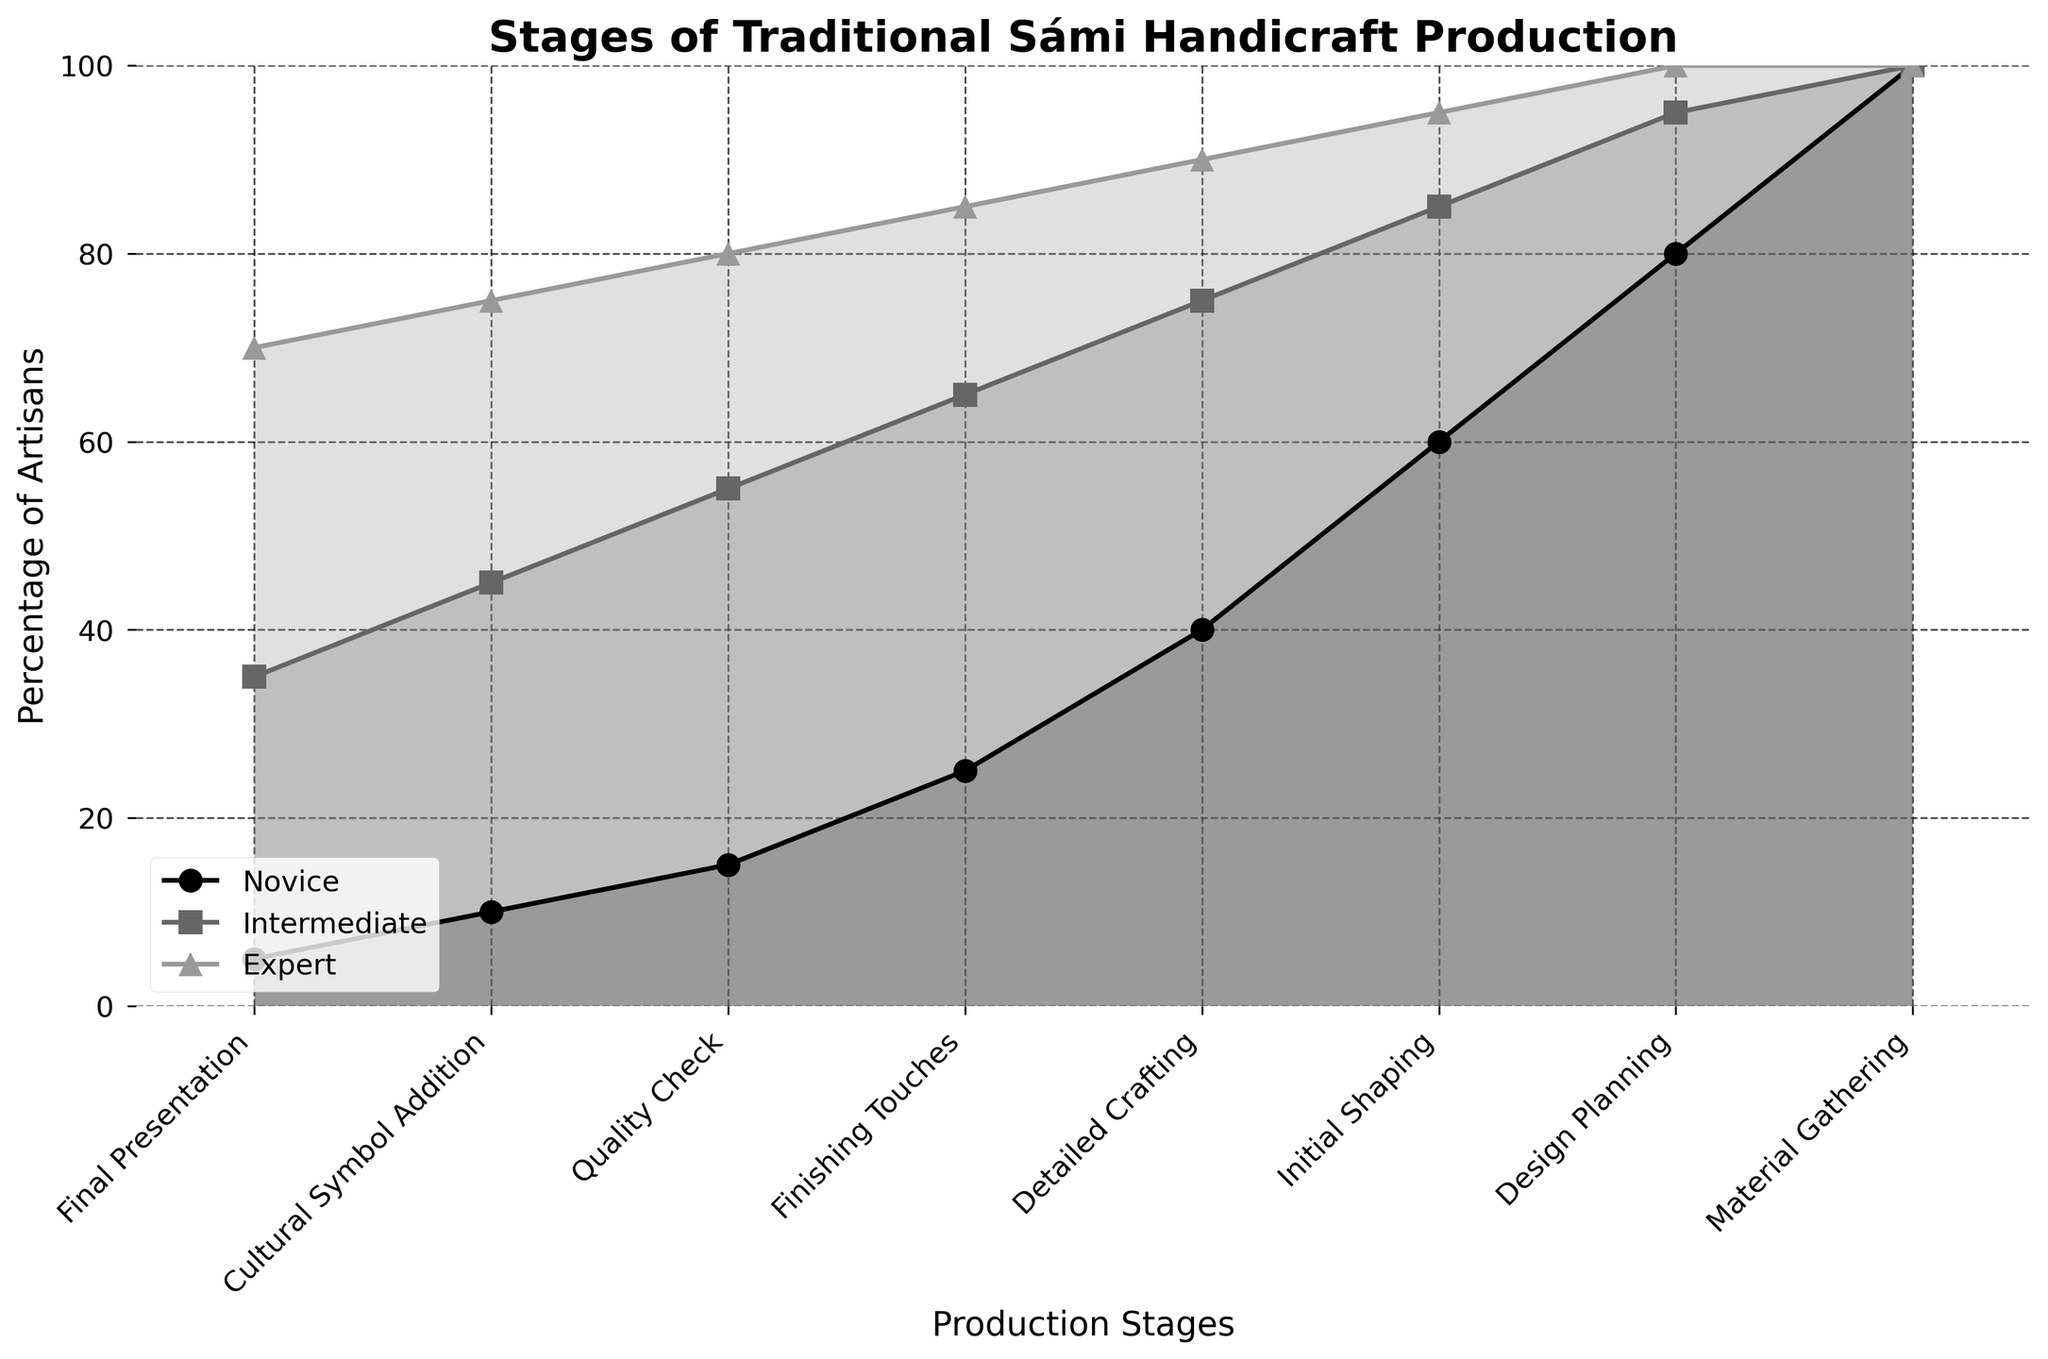What is the title of the figure? The title is usually located at the top of the figure, stating the main purpose or the topic of the visualization. The title of this particular figure should be visible and clear.
Answer: Stages of Traditional Sámi Handicraft Production How many production stages are shown in the figure? Count the number of distinct labels on the x-axis, which represent different stages.
Answer: 8 At which stage does the largest difference between novice and expert artisans occur? For each stage, identify the percentages of novice and expert artisans, then calculate the difference. The stage with the highest difference is the answer.
Answer: Final Presentation What is the percentage of novice artisans at the 'Quality Check' stage? Locate the 'Quality Check' stage on the x-axis, then follow the line to see the corresponding point for novice artisans.
Answer: 15% Which experience level has the steepest decline between 'Material Gathering' and 'Design Planning'? Compare the decline in percentages for novice, intermediate, and expert artisans between the 'Material Gathering' and 'Design Planning' stages. The steepest decline is the largest difference between these points.
Answer: Novice What stages have more than 50% of intermediate artisans? Identify the stages where the percentage of intermediate artisans is greater than 50% by looking at the plotted points for the intermediate line.
Answer: Design Planning, Initial Shaping, Detailed Crafting, Finishing Touches, Quality Check Between 'Detailed Crafting' and 'Cultural Symbol Addition,' how many stages see a dropping percentage in novice artisans? Identify consecutive stages from 'Detailed Crafting' to 'Cultural Symbol Addition' and count how many times the value for novice artisans decreases.
Answer: 3 stages Is there any stage where all experience levels show the same percentage? Check each stage to see if the plotted points for novice, intermediate, and expert artisans align, indicating equal percentages.
Answer: Material Gathering Compare the percentage of expert artisans at 'Initial Shaping' and 'Cultural Symbol Addition.' Which is higher, and by how much? Locate the percentages of expert artisans at these two stages and find the difference.
Answer: Initial Shaping is higher by 20% (95% at 'Initial Shaping' and 75% at 'Cultural Symbol Addition') Which stage represents the lowest percentage for intermediate artisans? Identify the plotted points for intermediate artisans across all stages and find the lowest value.
Answer: Final Presentation 